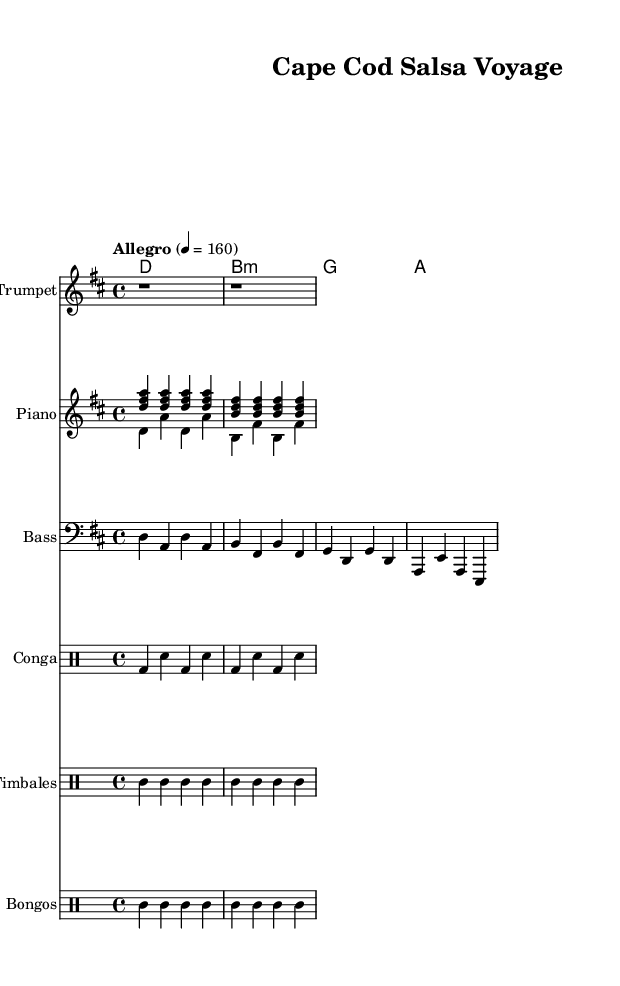What is the key signature of this music? The key signature is indicated by the number of sharps or flats on the staff. In this case, there are two sharps indicated (F# and C#), which signifies that the key is D major.
Answer: D major What is the time signature of the piece? The time signature is represented by the two numbers at the beginning of the score. Here, it shows a 4 over 4, meaning there are four beats in each measure and the quarter note gets one beat.
Answer: 4/4 What is the tempo marking for this composition? The tempo marking is listed right after the time signature and indicates the speed of the piece. It specifies "Allegro" and provides a metronome marking of 160 beats per minute, which suggests a fast pace.
Answer: Allegro, 160 How many measures are in the melody section? By counting the number of bar lines in the melody part, we can determine the number of measures. The melody has four measures in total based on the notation.
Answer: 4 What instruments are featured in this composition? We can identify the instruments from the labeled staves in the score. They include trumpet, piano, bass, conga, timbales, and bongos.
Answer: Trumpet, piano, bass, conga, timbales, bongos What rhythm pattern is used in the conga part? The conga part consists of a specific pattern repeated twice, which can be inferred from the drum notation. It shows a kick drum and snare pattern that alternates regularly.
Answer: Kick-Snare pattern What genre does this composition represent? The elements of the music, such as its rhythmic structure and instrumentation, clearly point towards the Latin genre, specifically resembling salsa influences.
Answer: Salsa 